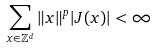<formula> <loc_0><loc_0><loc_500><loc_500>\sum _ { x \in \mathbb { Z } ^ { d } } \| x \| ^ { p } | J ( x ) | < \infty</formula> 